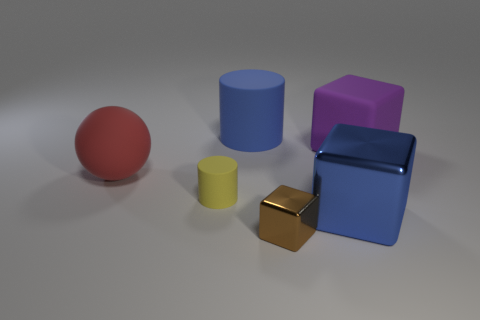Is the purple block made of the same material as the small brown thing?
Your answer should be compact. No. There is a cylinder that is in front of the purple rubber block; does it have the same size as the blue object behind the small yellow object?
Ensure brevity in your answer.  No. Are there fewer purple rubber cubes than big things?
Provide a succinct answer. Yes. What number of matte things are brown cubes or big purple blocks?
Your response must be concise. 1. Are there any big rubber cylinders that are behind the matte cylinder that is behind the large purple block?
Give a very brief answer. No. Is the material of the small thing in front of the blue shiny block the same as the small yellow cylinder?
Offer a terse response. No. What number of other objects are the same color as the small rubber thing?
Make the answer very short. 0. Do the big metal thing and the big matte cylinder have the same color?
Your answer should be compact. Yes. How big is the blue object that is in front of the tiny object to the left of the big cylinder?
Provide a short and direct response. Large. Is the blue thing that is to the left of the large shiny block made of the same material as the large cube in front of the ball?
Keep it short and to the point. No. 